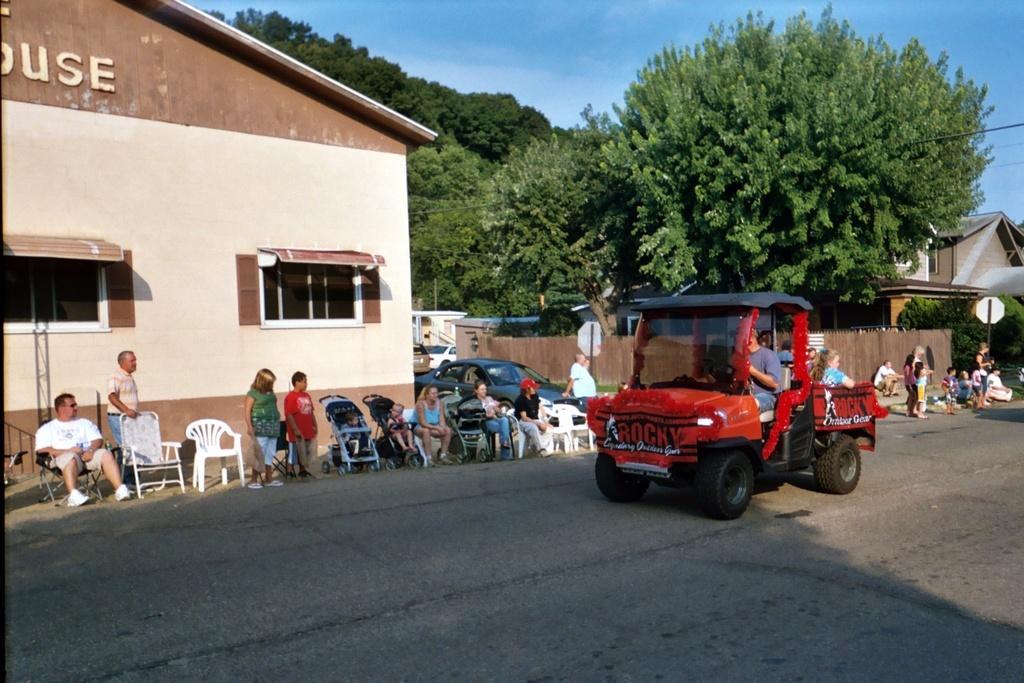How would you summarize this image in a sentence or two? In the image there is a vehicle on the road and behind the vehicle there are many people sitting on the chairs and some of them are standing, behind them there is a house and beside the house there are plenty of trees. 